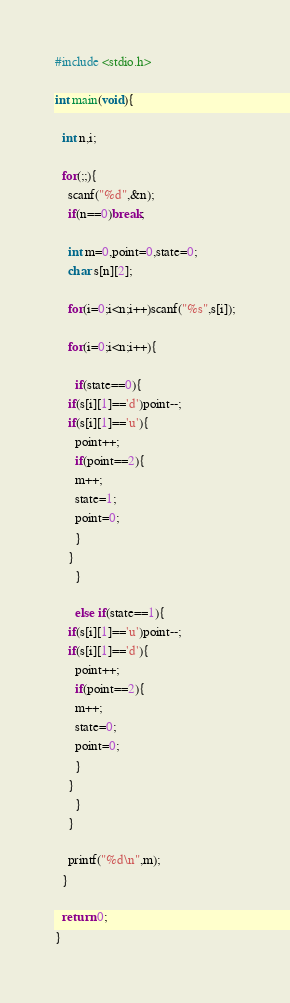Convert code to text. <code><loc_0><loc_0><loc_500><loc_500><_C_>#include <stdio.h>

int main(void){

  int n,i;

  for(;;){
    scanf("%d",&n);
    if(n==0)break;

    int m=0,point=0,state=0;
    char s[n][2];

    for(i=0;i<n;i++)scanf("%s",s[i]);

    for(i=0;i<n;i++){

      if(state==0){
	if(s[i][1]=='d')point--;
	if(s[i][1]=='u'){
	  point++;
	  if(point==2){
	  m++;
	  state=1;
	  point=0;
	  }
	}
      }

      else if(state==1){
	if(s[i][1]=='u')point--;
	if(s[i][1]=='d'){
	  point++;
	  if(point==2){
	  m++;
	  state=0;
	  point=0;
	  }
	}
      }
    }
    
    printf("%d\n",m);
  }

  return 0;
}</code> 